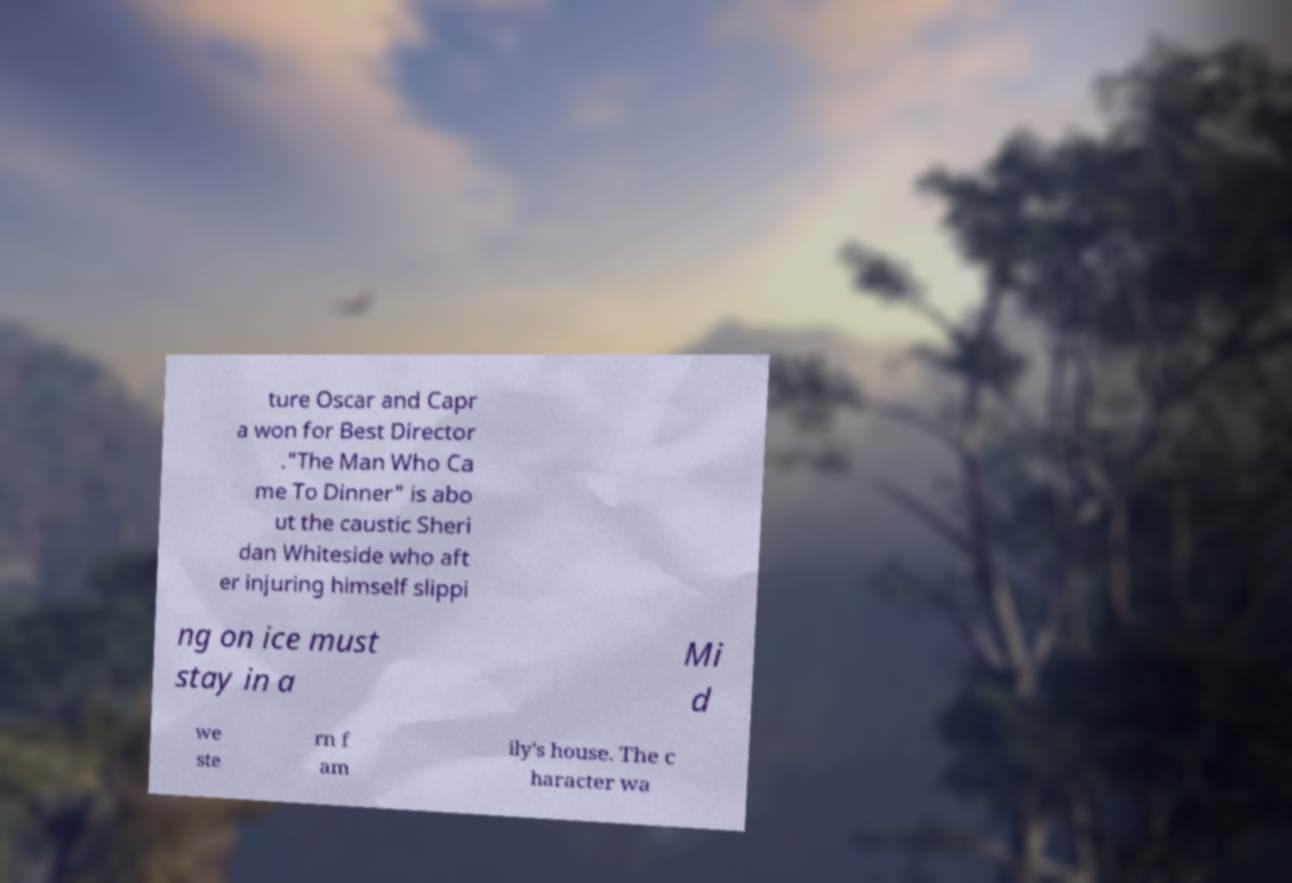Can you read and provide the text displayed in the image?This photo seems to have some interesting text. Can you extract and type it out for me? ture Oscar and Capr a won for Best Director ."The Man Who Ca me To Dinner" is abo ut the caustic Sheri dan Whiteside who aft er injuring himself slippi ng on ice must stay in a Mi d we ste rn f am ily's house. The c haracter wa 